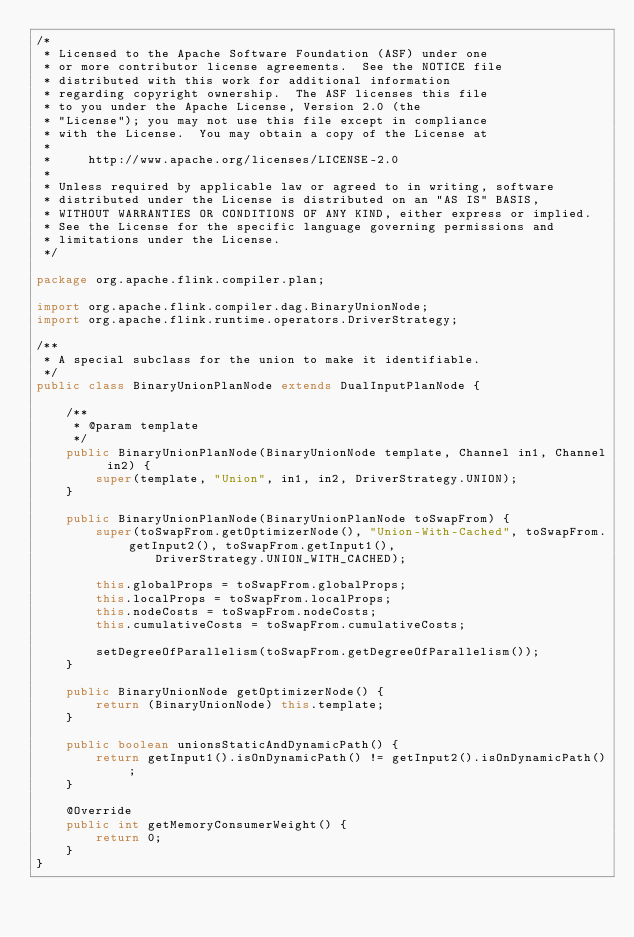<code> <loc_0><loc_0><loc_500><loc_500><_Java_>/*
 * Licensed to the Apache Software Foundation (ASF) under one
 * or more contributor license agreements.  See the NOTICE file
 * distributed with this work for additional information
 * regarding copyright ownership.  The ASF licenses this file
 * to you under the Apache License, Version 2.0 (the
 * "License"); you may not use this file except in compliance
 * with the License.  You may obtain a copy of the License at
 *
 *     http://www.apache.org/licenses/LICENSE-2.0
 *
 * Unless required by applicable law or agreed to in writing, software
 * distributed under the License is distributed on an "AS IS" BASIS,
 * WITHOUT WARRANTIES OR CONDITIONS OF ANY KIND, either express or implied.
 * See the License for the specific language governing permissions and
 * limitations under the License.
 */

package org.apache.flink.compiler.plan;

import org.apache.flink.compiler.dag.BinaryUnionNode;
import org.apache.flink.runtime.operators.DriverStrategy;

/**
 * A special subclass for the union to make it identifiable.
 */
public class BinaryUnionPlanNode extends DualInputPlanNode {
	
	/**
	 * @param template
	 */
	public BinaryUnionPlanNode(BinaryUnionNode template, Channel in1, Channel in2) {
		super(template, "Union", in1, in2, DriverStrategy.UNION);
	}
	
	public BinaryUnionPlanNode(BinaryUnionPlanNode toSwapFrom) {
		super(toSwapFrom.getOptimizerNode(), "Union-With-Cached", toSwapFrom.getInput2(), toSwapFrom.getInput1(),
				DriverStrategy.UNION_WITH_CACHED);
		
		this.globalProps = toSwapFrom.globalProps;
		this.localProps = toSwapFrom.localProps;
		this.nodeCosts = toSwapFrom.nodeCosts;
		this.cumulativeCosts = toSwapFrom.cumulativeCosts;
		
		setDegreeOfParallelism(toSwapFrom.getDegreeOfParallelism());
	}
	
	public BinaryUnionNode getOptimizerNode() {
		return (BinaryUnionNode) this.template;
	}
	
	public boolean unionsStaticAndDynamicPath() {
		return getInput1().isOnDynamicPath() != getInput2().isOnDynamicPath();
	}
	
	@Override
	public int getMemoryConsumerWeight() {
		return 0;
	}
}
</code> 